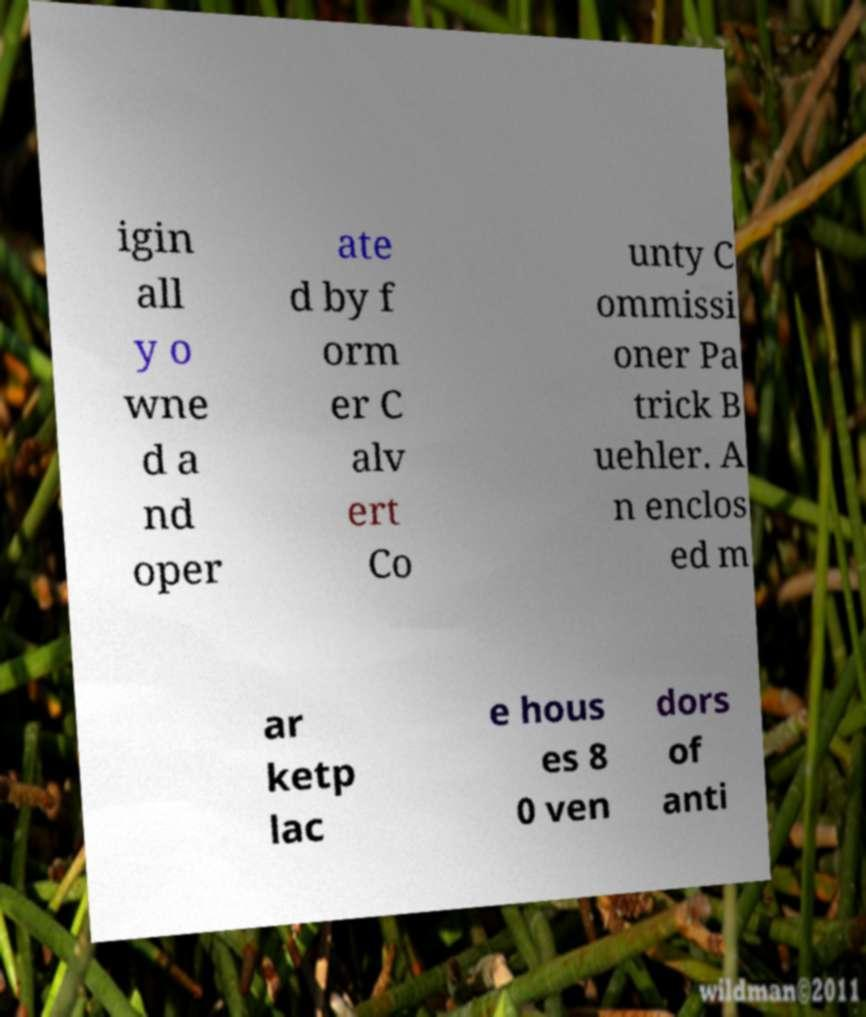Please identify and transcribe the text found in this image. igin all y o wne d a nd oper ate d by f orm er C alv ert Co unty C ommissi oner Pa trick B uehler. A n enclos ed m ar ketp lac e hous es 8 0 ven dors of anti 